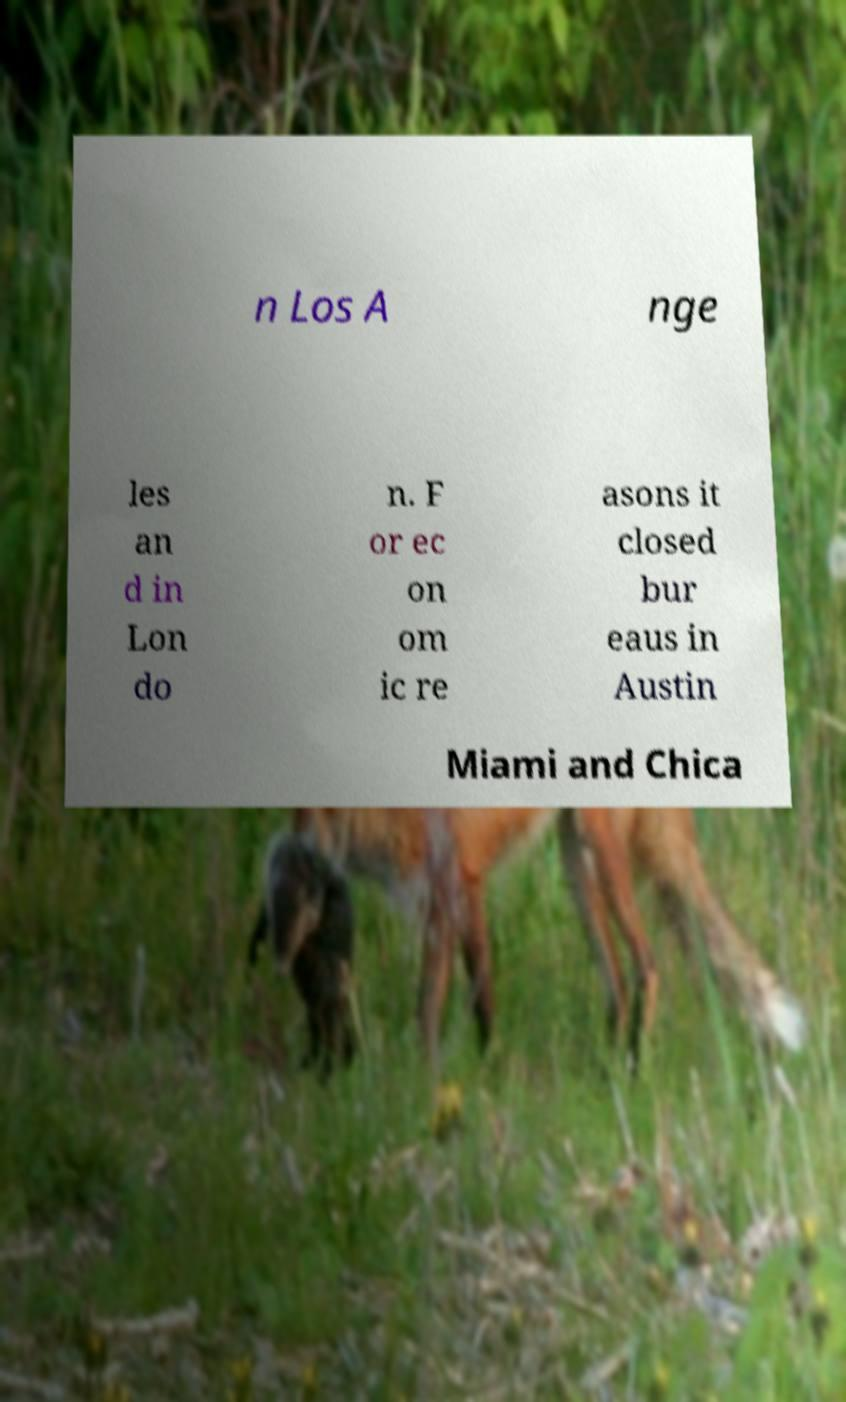Could you assist in decoding the text presented in this image and type it out clearly? n Los A nge les an d in Lon do n. F or ec on om ic re asons it closed bur eaus in Austin Miami and Chica 